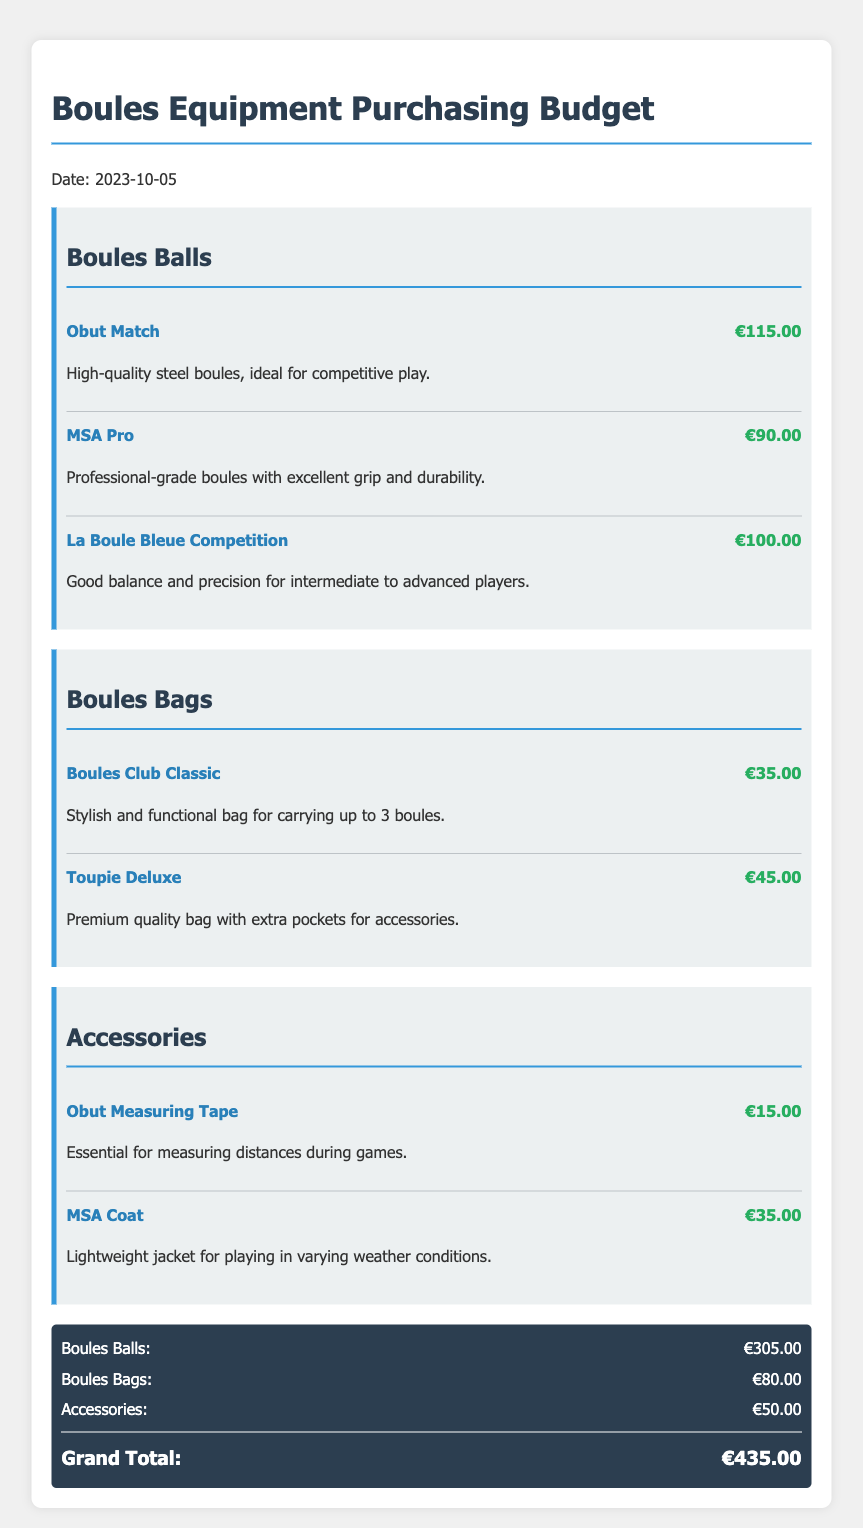What is the date of the budget? The date of the budget is specified at the top of the document.
Answer: 2023-10-05 What is the brand of the most expensive boules? The brands listed under Boules Balls can be compared to find the most expensive one.
Answer: Obut Match What is the price of the La Boule Bleue Competition? The price is provided next to the product under Boules Balls.
Answer: €100.00 How many boules can the Boules Club Classic bag carry? The description of the Boules Club Classic bag states its capacity.
Answer: 3 boules What is the total cost for Boules Bags? The total for Boules Bags is mentioned in the summary of costs at the bottom of the document.
Answer: €80.00 What is the price of the most expensive accessory? The prices of the accessories can be compared to find the most expensive one.
Answer: €35.00 How much does a measuring tape cost? The price of the Obut Measuring Tape is detailed in the Accessories section.
Answer: €15.00 What is the grand total of the budget? The grand total is calculated from the totals of all categories at the end of the document.
Answer: €435.00 What type of product is MSA Pro? The type of product is indicated in the list of Boules Balls.
Answer: Boules Ball 